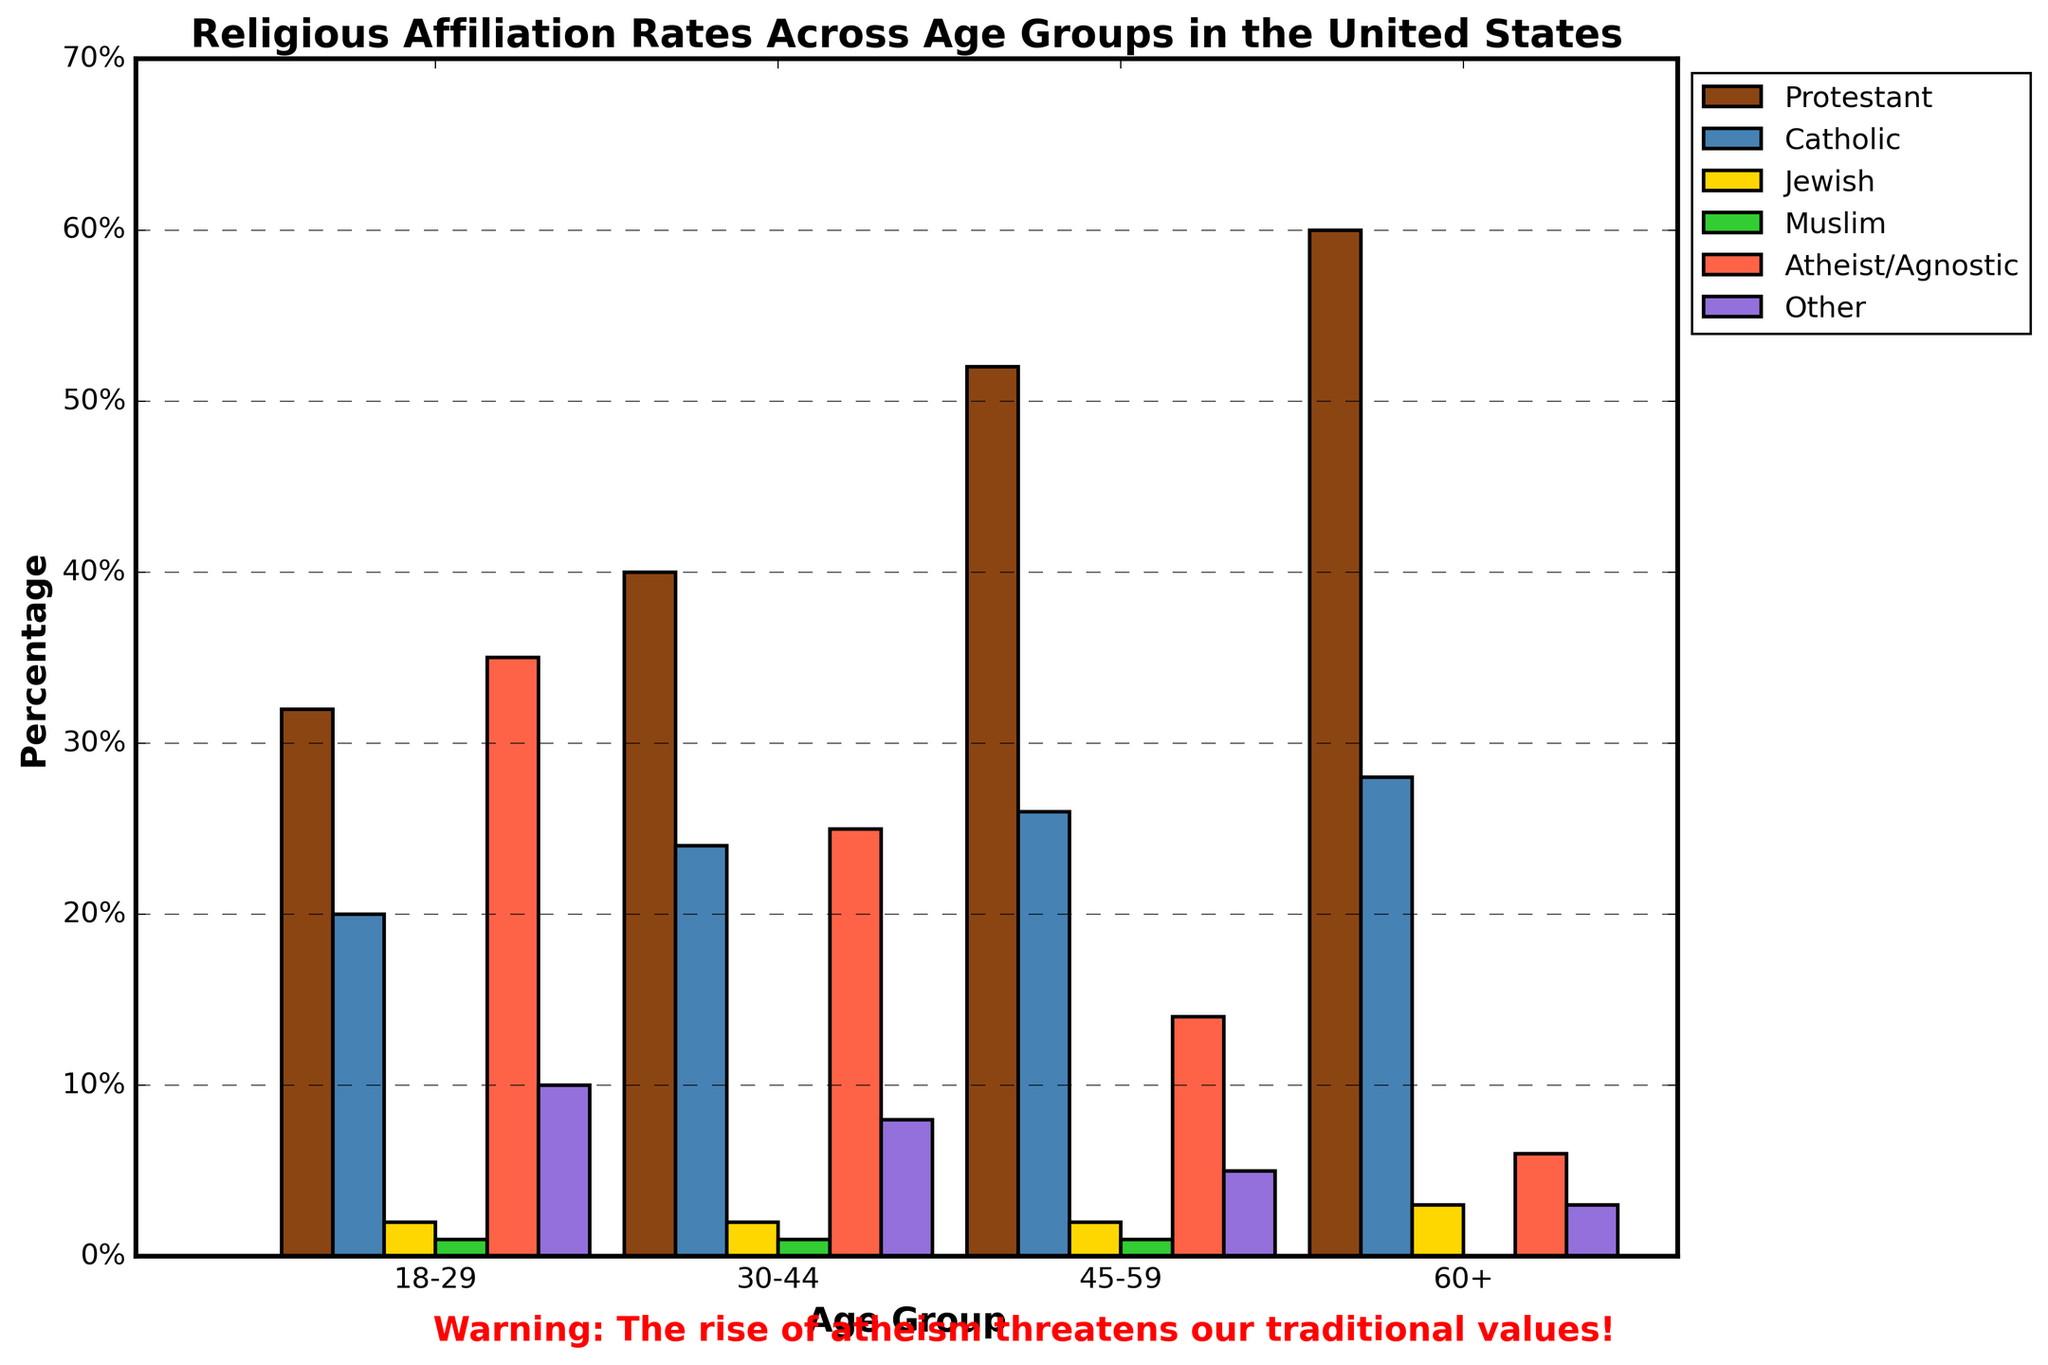What is the percentage of Atheist/Agnostic in the 30-44 age group? Locate the "30-44" age group on the x-axis and identify the corresponding bar for "Atheist/Agnostic". Read the height of the bar.
Answer: 25% Which age group has the highest percentage of Protestants? Look for the tallest "Protestant" bar among all age groups. The "60+" age group has the tallest bar.
Answer: 60+ How much higher is the percentage of Catholics in the 60+ age group compared to the 18-29 age group? Find the "Catholic" bar for both age groups and measure the difference in their heights: 28% (60+) - 20% (18-29) = 8%.
Answer: 8% Sum the percentages of Jewish and Muslim affiliations in the 45-59 age group. Locate the "45-59" age group and add the heights of "Jewish" (2%) and "Muslim" (1%) bars: 2% + 1% = 3%.
Answer: 3% What is the total percentage of Protestants and Catholics in the 18-29 age group? Find the "Protestant" and "Catholic" bars for the "18-29" age group and sum their heights: 32% (Protestant) + 20% (Catholic) = 52%.
Answer: 52% Which two age groups have the same percentage of Jewish affiliation? Identify the bars for "Jewish" affiliation across all age groups. Both the "18-29" and "30-44" age groups have 2%.
Answer: 18-29 and 30-44 Across all age groups, which affiliation has the lowest consistent percentage? Review all affiliation bars across age groups. "Muslim" has consistently low percentages (1%, 1%, 1%, 0%).
Answer: Muslim Compare the percentage of Atheist/Agnostic in the 45-59 age group with the 60+ age group. Which one is higher and by how much? Find the "Atheist/Agnostic" bars for both age groups and subtract: 14% (45-59) - 6% (60+) = 8%. The 45-59 age group has a higher percentage by 8%.
Answer: 45-59 by 8% Identify the age group with the highest percentage of people affiliated with "Other" religions. Locate the tallest "Other" bar among all age groups. The "18-29" age group has the highest bar at 10%.
Answer: 18-29 